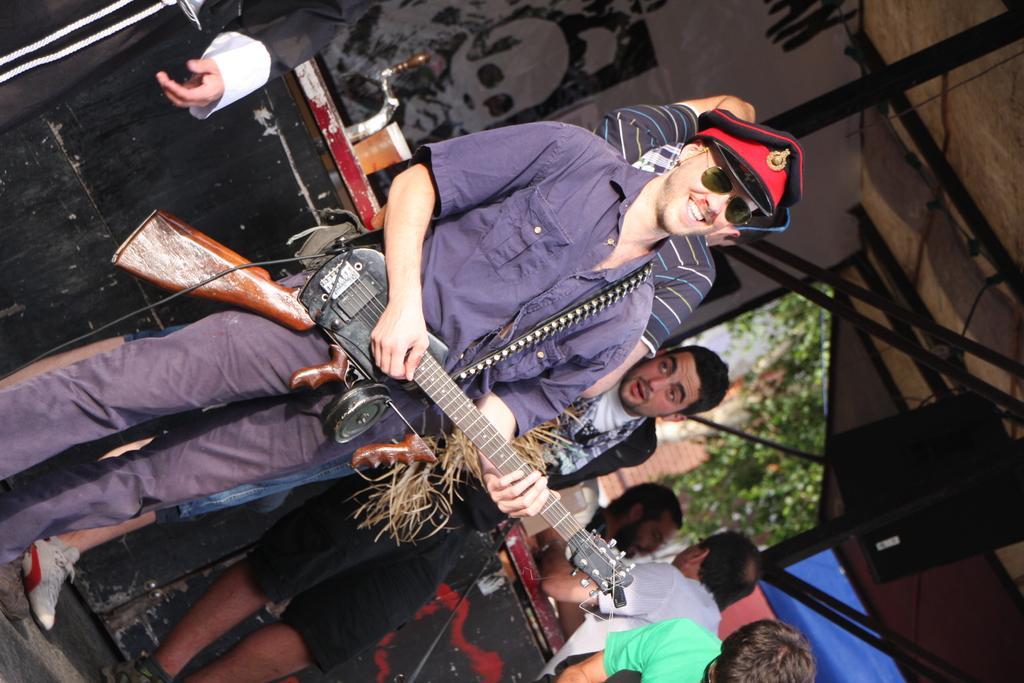Could you give a brief overview of what you see in this image? This picture shows a man Standing and playing guitar with a smile on his face and he wore a cap on is head and we see few people standing on the side and we see a beer glass and a poster on the back and we see a tree on the side 